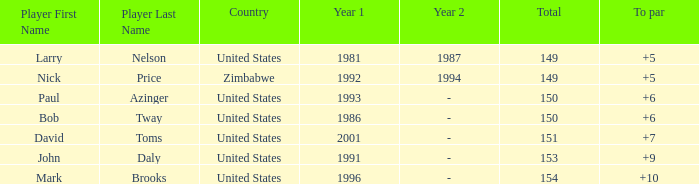What is the total for 1986 with a to par higher than 6? 0.0. 